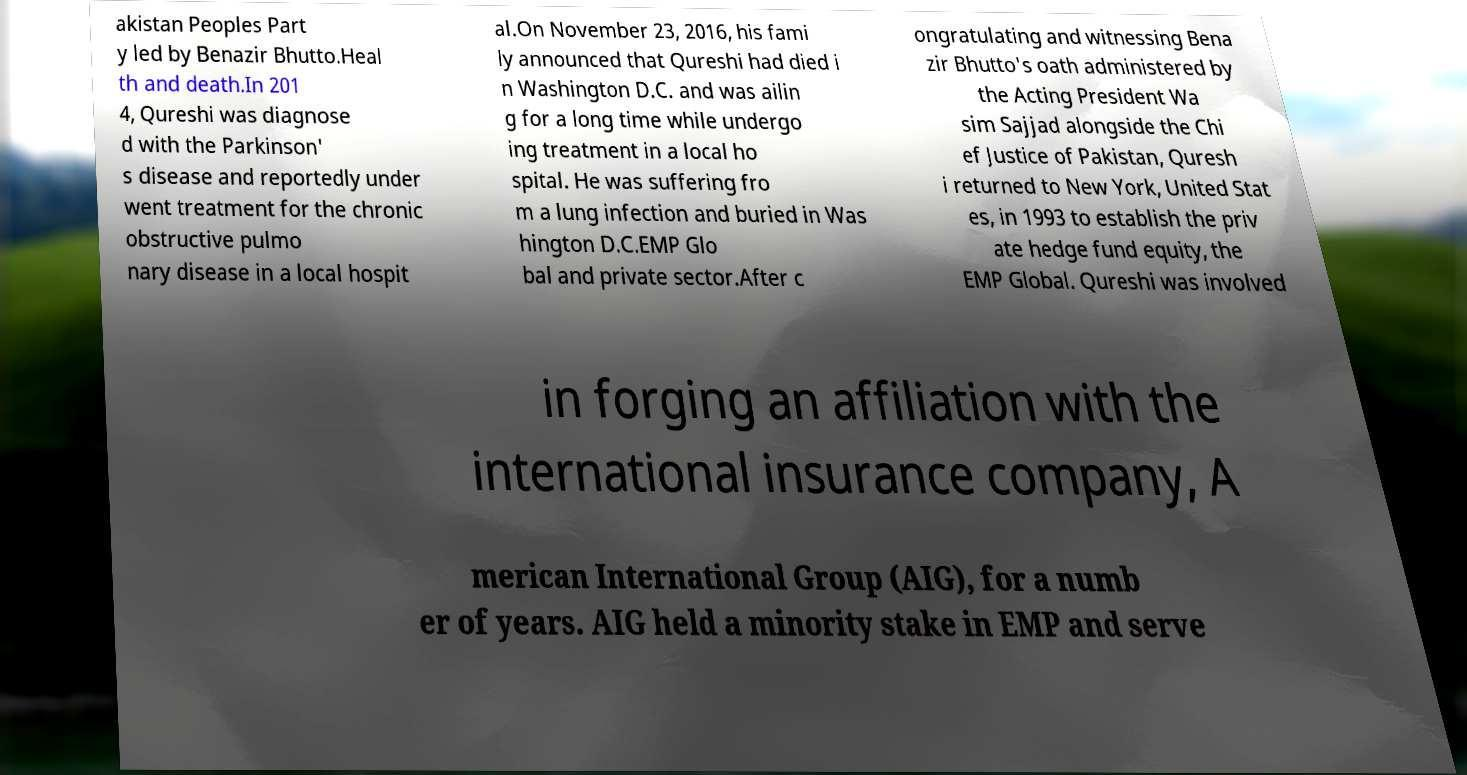There's text embedded in this image that I need extracted. Can you transcribe it verbatim? akistan Peoples Part y led by Benazir Bhutto.Heal th and death.In 201 4, Qureshi was diagnose d with the Parkinson' s disease and reportedly under went treatment for the chronic obstructive pulmo nary disease in a local hospit al.On November 23, 2016, his fami ly announced that Qureshi had died i n Washington D.C. and was ailin g for a long time while undergo ing treatment in a local ho spital. He was suffering fro m a lung infection and buried in Was hington D.C.EMP Glo bal and private sector.After c ongratulating and witnessing Bena zir Bhutto's oath administered by the Acting President Wa sim Sajjad alongside the Chi ef Justice of Pakistan, Quresh i returned to New York, United Stat es, in 1993 to establish the priv ate hedge fund equity, the EMP Global. Qureshi was involved in forging an affiliation with the international insurance company, A merican International Group (AIG), for a numb er of years. AIG held a minority stake in EMP and serve 